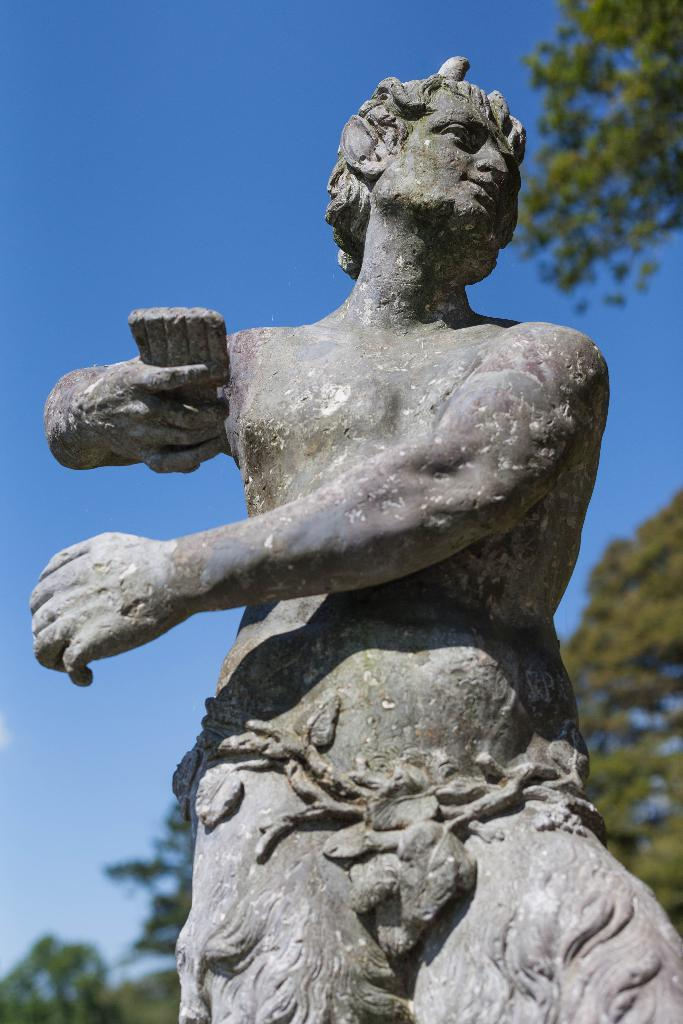What is the main subject in the foreground of the image? There is a sculpture in the foreground of the image. What can be seen in the background of the image? There are trees and the sky visible in the background of the image. Reasoning: Let' Let's think step by step in order to produce the conversation. We start by identifying the main subject in the foreground, which is the sculpture. Then, we describe the background of the image, mentioning the presence of trees and the sky. We avoid making any assumptions about the sculpture or the image's context and focus on the facts provided. Absurd Question/Question/Answer: What type of beef dish is being served on a plate in the image? There is no beef dish or plate present in the image; it features a sculpture in the foreground and trees and the sky in the background. Are there any toys visible in the image? There are no toys present in the image; it features a sculpture in the foreground and trees and the sky in the background. 